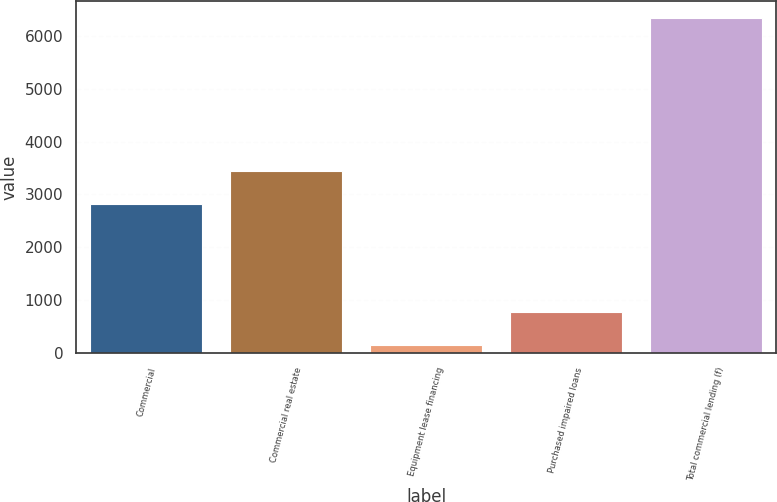Convert chart. <chart><loc_0><loc_0><loc_500><loc_500><bar_chart><fcel>Commercial<fcel>Commercial real estate<fcel>Equipment lease financing<fcel>Purchased impaired loans<fcel>Total commercial lending (f)<nl><fcel>2817<fcel>3435.2<fcel>153<fcel>771.2<fcel>6335<nl></chart> 